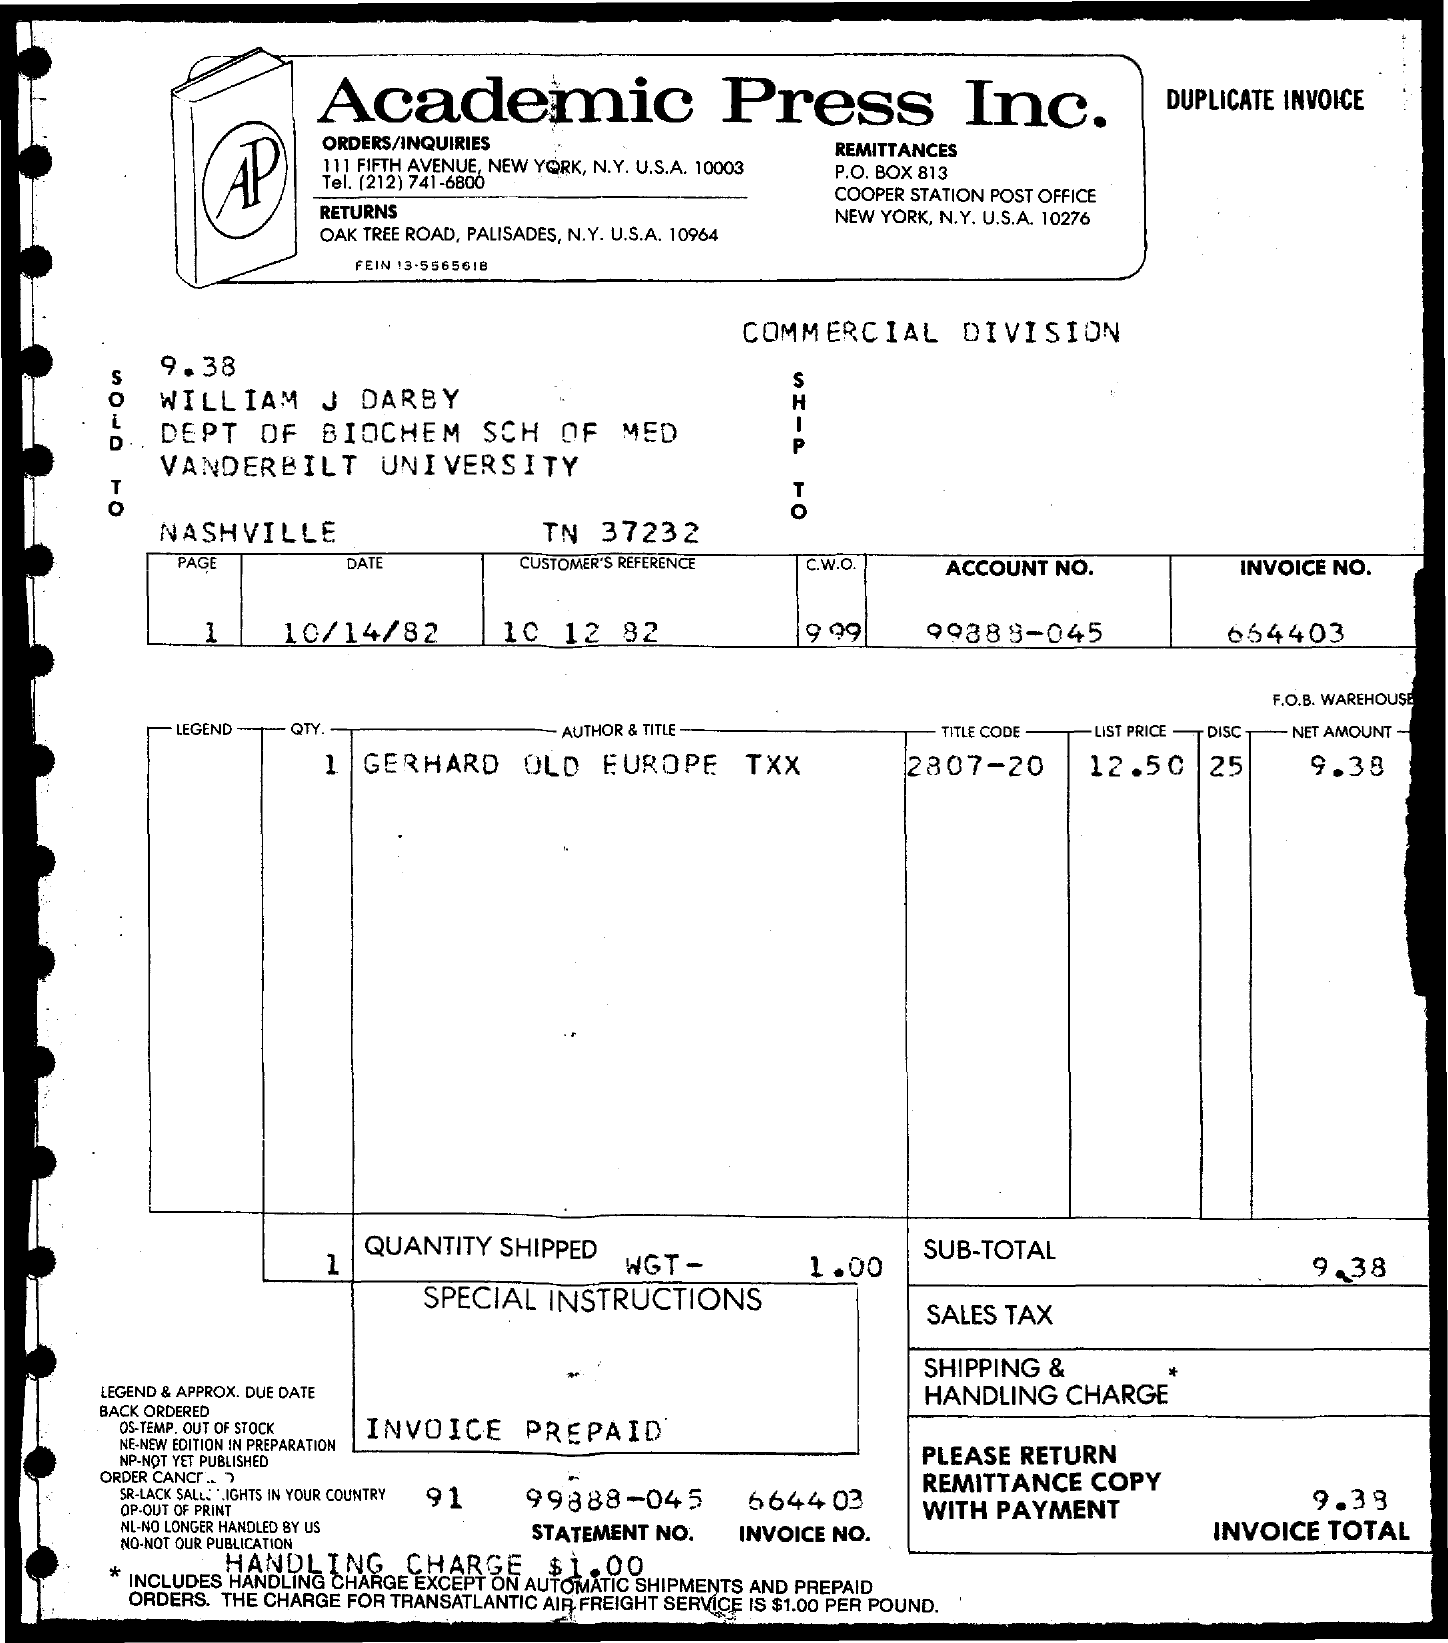What is the net amount? The net amount on the invoice is $9.38, which is the total cost for the item 'GERHARD OLD EUROPE TXX' before any additional charges such as shipping, handling, and sales tax are applied. 